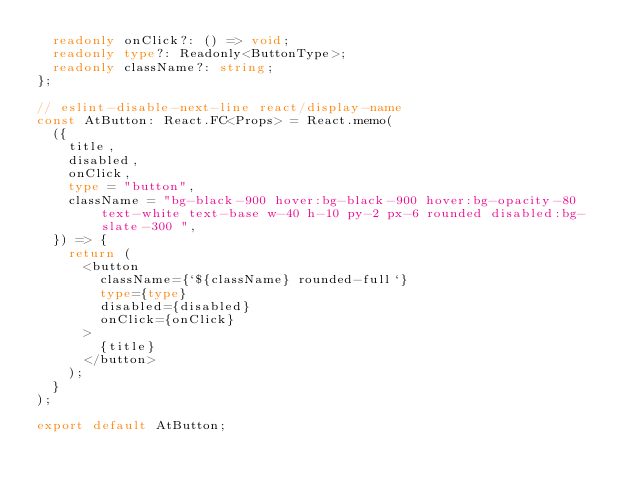Convert code to text. <code><loc_0><loc_0><loc_500><loc_500><_TypeScript_>  readonly onClick?: () => void;
  readonly type?: Readonly<ButtonType>;
  readonly className?: string;
};

// eslint-disable-next-line react/display-name
const AtButton: React.FC<Props> = React.memo(
  ({
    title,
    disabled,
    onClick,
    type = "button",
    className = "bg-black-900 hover:bg-black-900 hover:bg-opacity-80 text-white text-base w-40 h-10 py-2 px-6 rounded disabled:bg-slate-300	",
  }) => {
    return (
      <button
        className={`${className} rounded-full`}
        type={type}
        disabled={disabled}
        onClick={onClick}
      >
        {title}
      </button>
    );
  }
);

export default AtButton;
</code> 